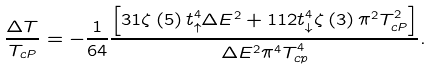<formula> <loc_0><loc_0><loc_500><loc_500>\frac { \Delta T } { T _ { c P } } = - \frac { 1 } { 6 4 } \frac { \left [ 3 1 \zeta \left ( 5 \right ) t _ { \uparrow } ^ { 4 } \Delta E ^ { 2 } + 1 1 2 t _ { \downarrow } ^ { 4 } \zeta \left ( 3 \right ) \pi ^ { 2 } T _ { c P } ^ { 2 } \right ] } { \Delta E ^ { 2 } \pi ^ { 4 } T _ { c p } ^ { 4 } } .</formula> 